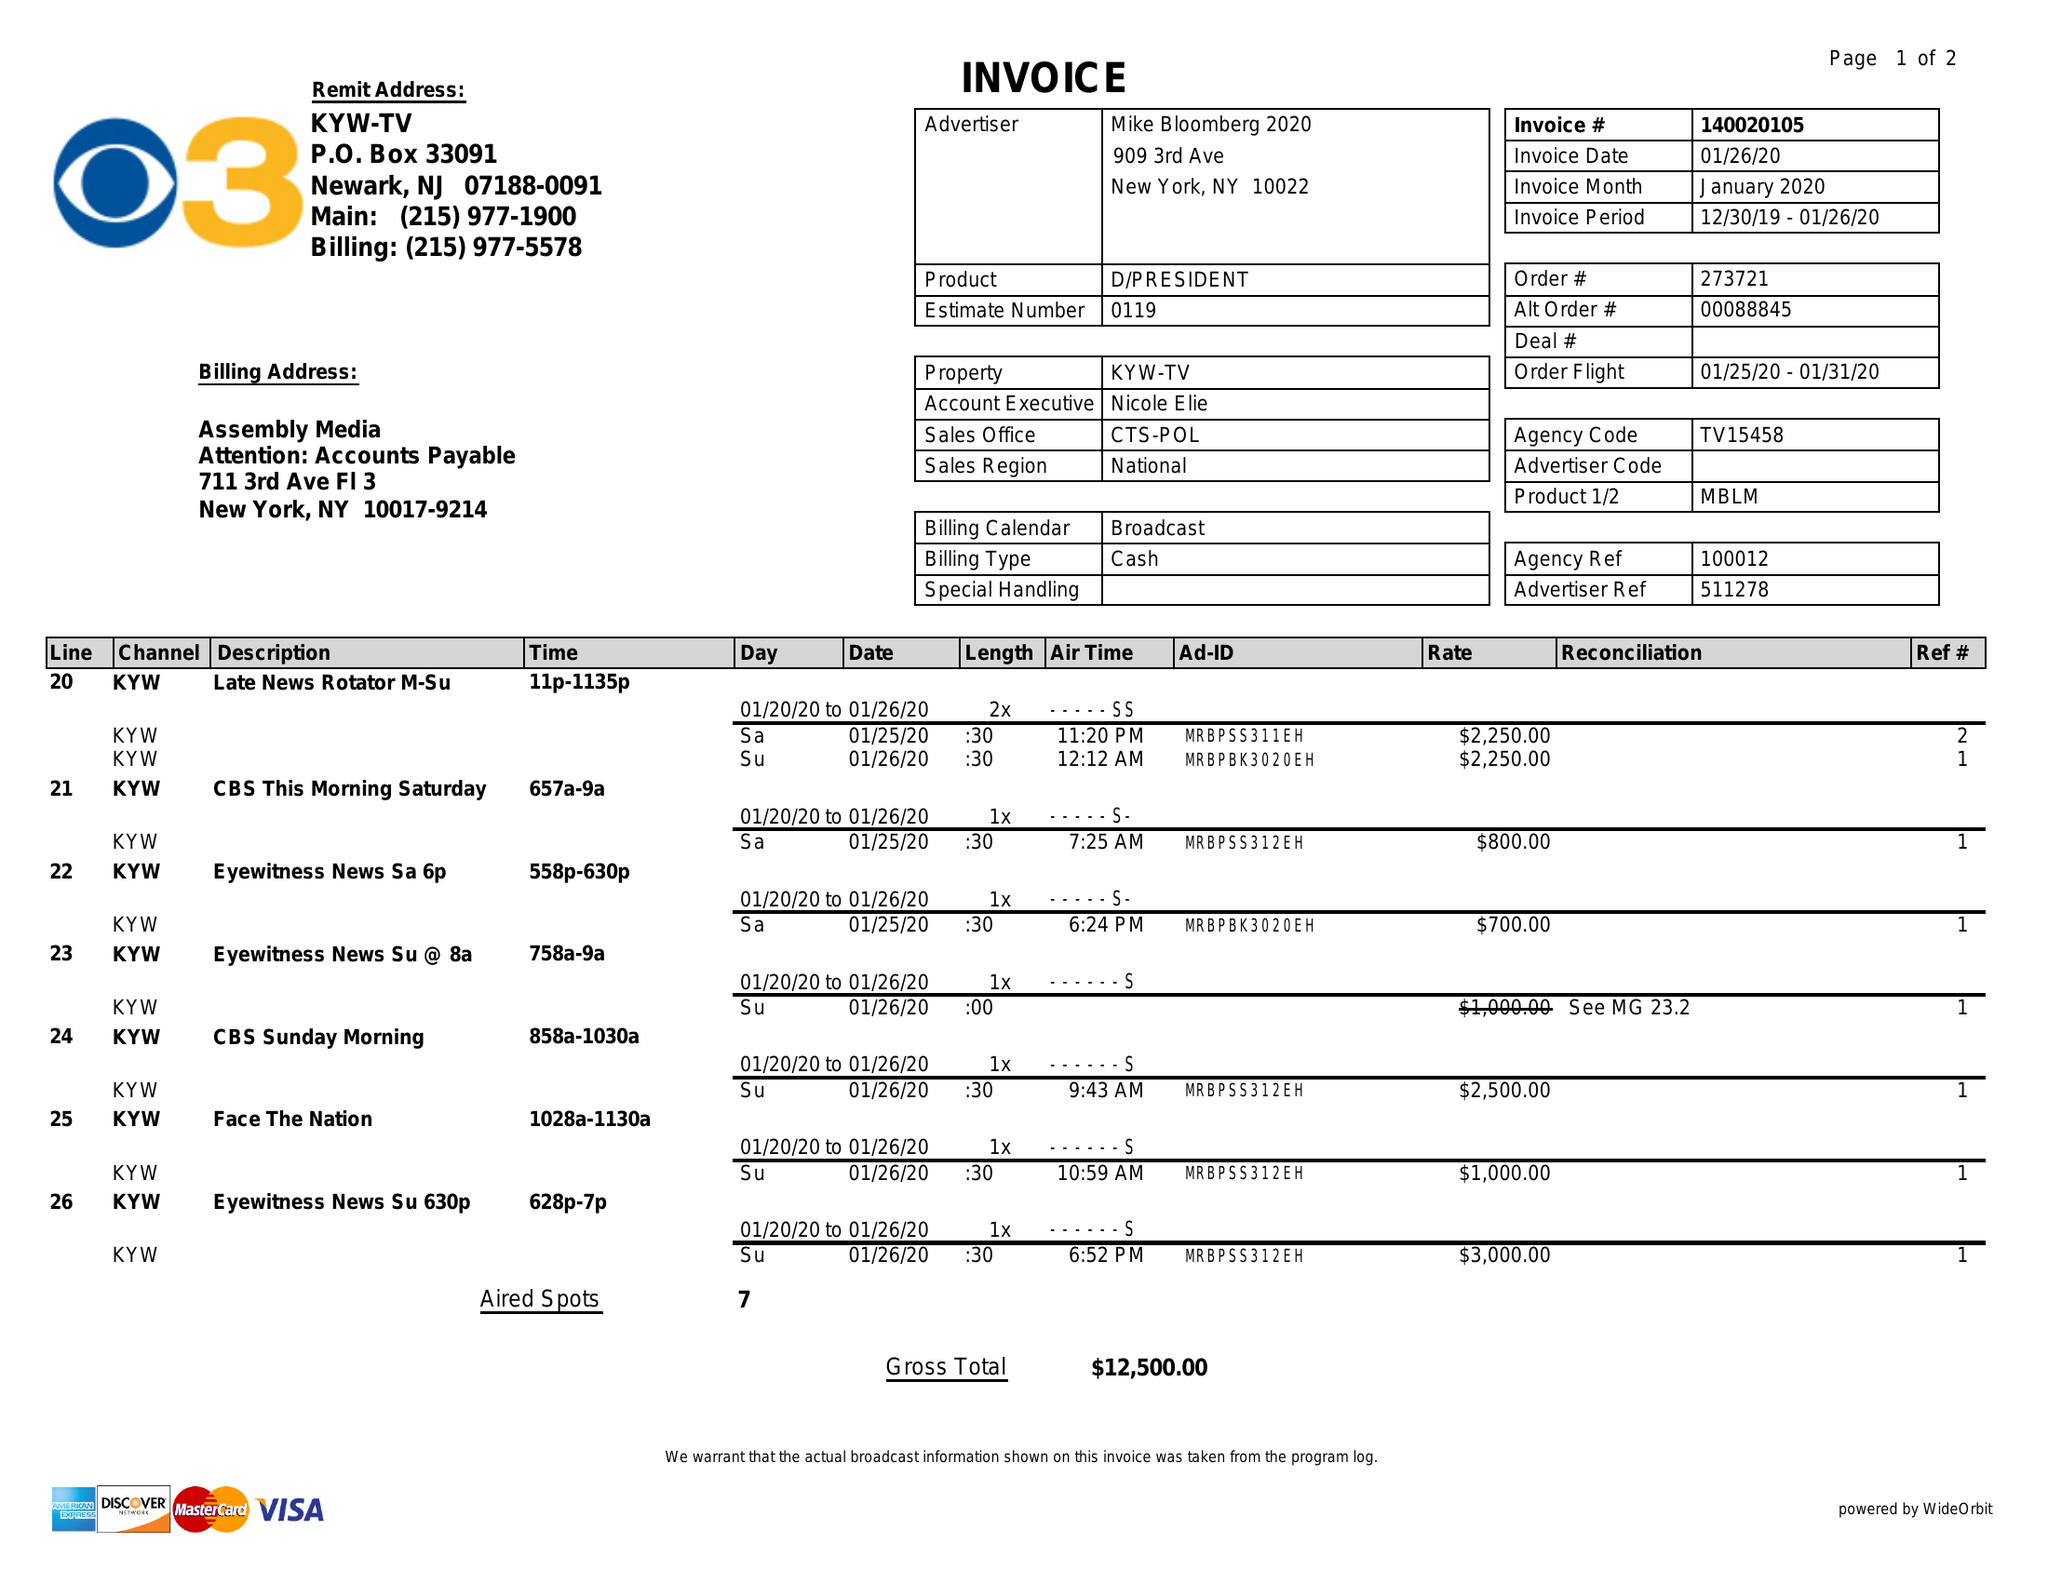What is the value for the contract_num?
Answer the question using a single word or phrase. 140020105 